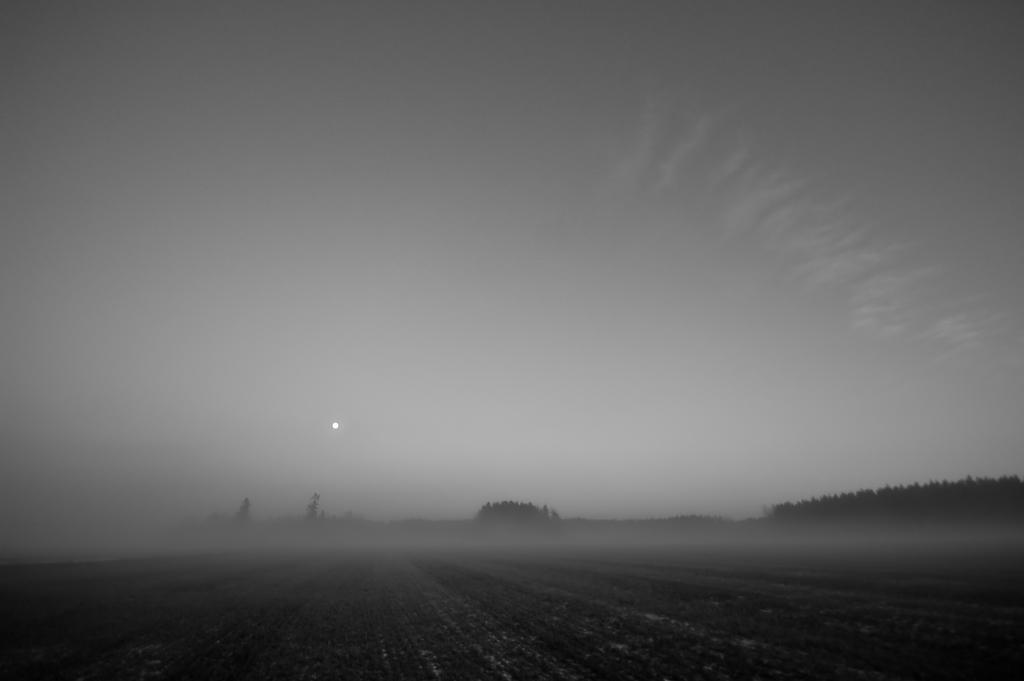How would you summarize this image in a sentence or two? In this picture, in the middle to right side, we can see some trees. On top there is a roof and sky. 